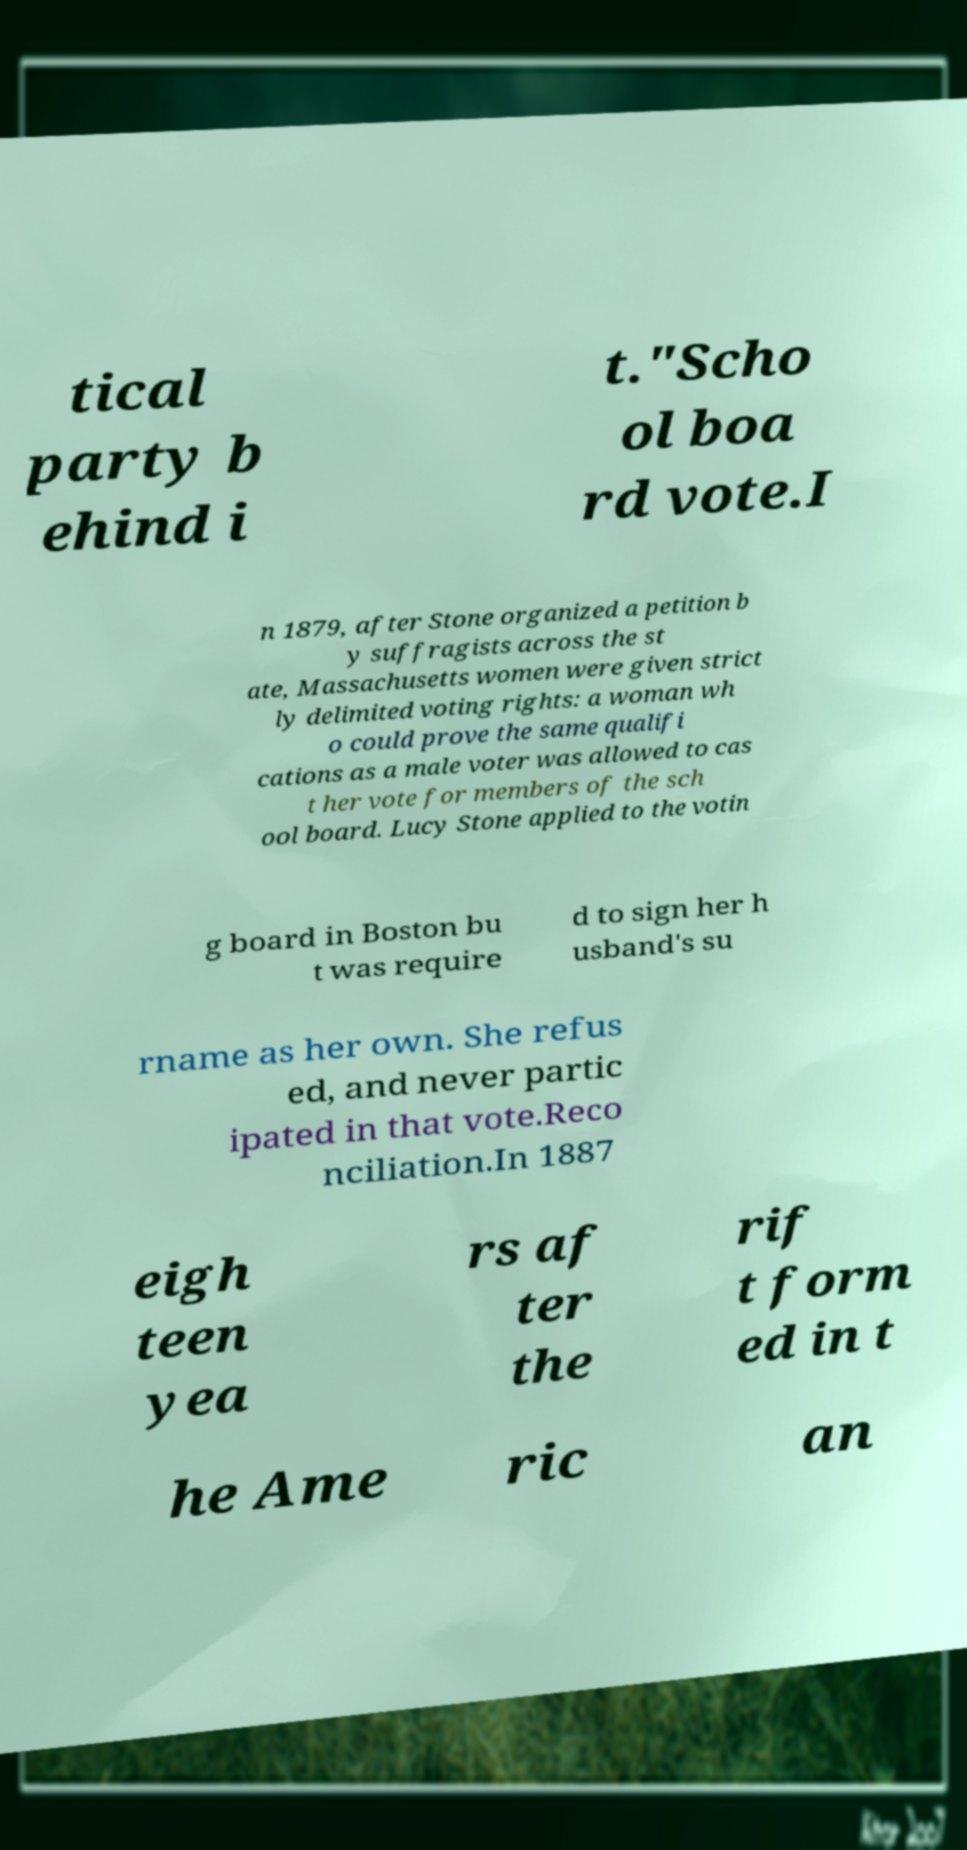Please read and relay the text visible in this image. What does it say? tical party b ehind i t."Scho ol boa rd vote.I n 1879, after Stone organized a petition b y suffragists across the st ate, Massachusetts women were given strict ly delimited voting rights: a woman wh o could prove the same qualifi cations as a male voter was allowed to cas t her vote for members of the sch ool board. Lucy Stone applied to the votin g board in Boston bu t was require d to sign her h usband's su rname as her own. She refus ed, and never partic ipated in that vote.Reco nciliation.In 1887 eigh teen yea rs af ter the rif t form ed in t he Ame ric an 